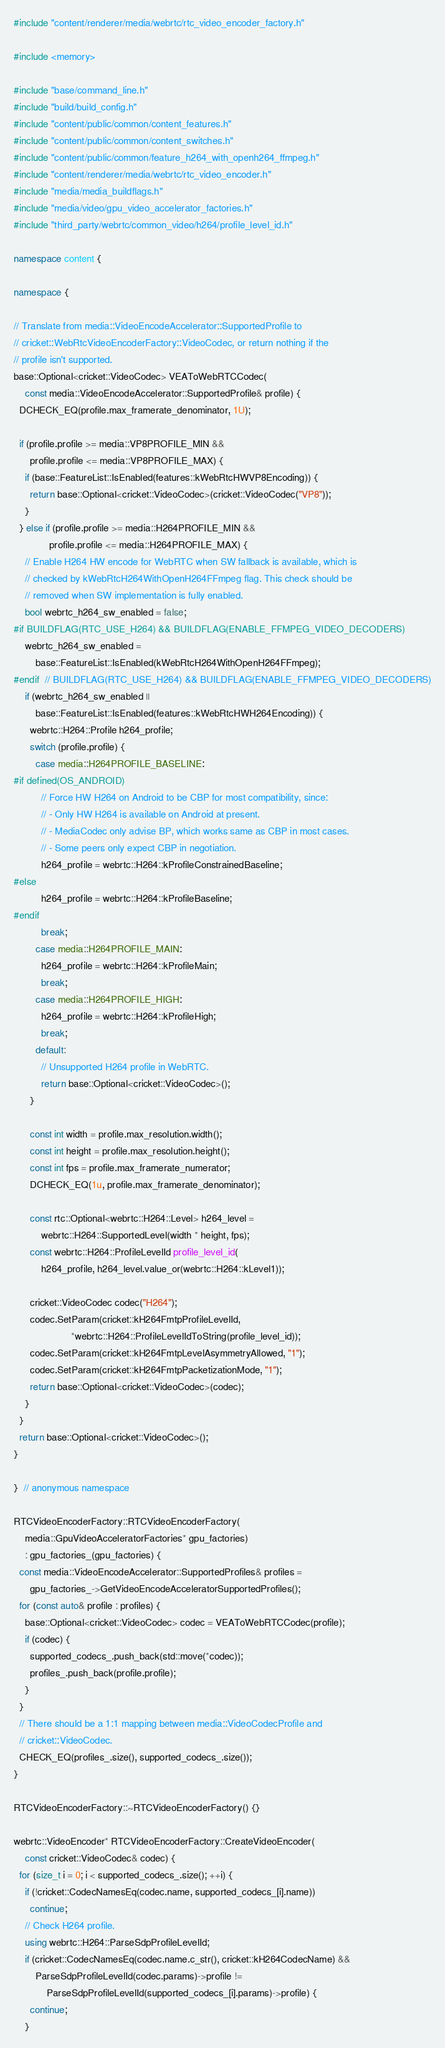<code> <loc_0><loc_0><loc_500><loc_500><_C++_>
#include "content/renderer/media/webrtc/rtc_video_encoder_factory.h"

#include <memory>

#include "base/command_line.h"
#include "build/build_config.h"
#include "content/public/common/content_features.h"
#include "content/public/common/content_switches.h"
#include "content/public/common/feature_h264_with_openh264_ffmpeg.h"
#include "content/renderer/media/webrtc/rtc_video_encoder.h"
#include "media/media_buildflags.h"
#include "media/video/gpu_video_accelerator_factories.h"
#include "third_party/webrtc/common_video/h264/profile_level_id.h"

namespace content {

namespace {

// Translate from media::VideoEncodeAccelerator::SupportedProfile to
// cricket::WebRtcVideoEncoderFactory::VideoCodec, or return nothing if the
// profile isn't supported.
base::Optional<cricket::VideoCodec> VEAToWebRTCCodec(
    const media::VideoEncodeAccelerator::SupportedProfile& profile) {
  DCHECK_EQ(profile.max_framerate_denominator, 1U);

  if (profile.profile >= media::VP8PROFILE_MIN &&
      profile.profile <= media::VP8PROFILE_MAX) {
    if (base::FeatureList::IsEnabled(features::kWebRtcHWVP8Encoding)) {
      return base::Optional<cricket::VideoCodec>(cricket::VideoCodec("VP8"));
    }
  } else if (profile.profile >= media::H264PROFILE_MIN &&
             profile.profile <= media::H264PROFILE_MAX) {
    // Enable H264 HW encode for WebRTC when SW fallback is available, which is
    // checked by kWebRtcH264WithOpenH264FFmpeg flag. This check should be
    // removed when SW implementation is fully enabled.
    bool webrtc_h264_sw_enabled = false;
#if BUILDFLAG(RTC_USE_H264) && BUILDFLAG(ENABLE_FFMPEG_VIDEO_DECODERS)
    webrtc_h264_sw_enabled =
        base::FeatureList::IsEnabled(kWebRtcH264WithOpenH264FFmpeg);
#endif  // BUILDFLAG(RTC_USE_H264) && BUILDFLAG(ENABLE_FFMPEG_VIDEO_DECODERS)
    if (webrtc_h264_sw_enabled ||
        base::FeatureList::IsEnabled(features::kWebRtcHWH264Encoding)) {
      webrtc::H264::Profile h264_profile;
      switch (profile.profile) {
        case media::H264PROFILE_BASELINE:
#if defined(OS_ANDROID)
          // Force HW H264 on Android to be CBP for most compatibility, since:
          // - Only HW H264 is available on Android at present.
          // - MediaCodec only advise BP, which works same as CBP in most cases.
          // - Some peers only expect CBP in negotiation.
          h264_profile = webrtc::H264::kProfileConstrainedBaseline;
#else
          h264_profile = webrtc::H264::kProfileBaseline;
#endif
          break;
        case media::H264PROFILE_MAIN:
          h264_profile = webrtc::H264::kProfileMain;
          break;
        case media::H264PROFILE_HIGH:
          h264_profile = webrtc::H264::kProfileHigh;
          break;
        default:
          // Unsupported H264 profile in WebRTC.
          return base::Optional<cricket::VideoCodec>();
      }

      const int width = profile.max_resolution.width();
      const int height = profile.max_resolution.height();
      const int fps = profile.max_framerate_numerator;
      DCHECK_EQ(1u, profile.max_framerate_denominator);

      const rtc::Optional<webrtc::H264::Level> h264_level =
          webrtc::H264::SupportedLevel(width * height, fps);
      const webrtc::H264::ProfileLevelId profile_level_id(
          h264_profile, h264_level.value_or(webrtc::H264::kLevel1));

      cricket::VideoCodec codec("H264");
      codec.SetParam(cricket::kH264FmtpProfileLevelId,
                     *webrtc::H264::ProfileLevelIdToString(profile_level_id));
      codec.SetParam(cricket::kH264FmtpLevelAsymmetryAllowed, "1");
      codec.SetParam(cricket::kH264FmtpPacketizationMode, "1");
      return base::Optional<cricket::VideoCodec>(codec);
    }
  }
  return base::Optional<cricket::VideoCodec>();
}

}  // anonymous namespace

RTCVideoEncoderFactory::RTCVideoEncoderFactory(
    media::GpuVideoAcceleratorFactories* gpu_factories)
    : gpu_factories_(gpu_factories) {
  const media::VideoEncodeAccelerator::SupportedProfiles& profiles =
      gpu_factories_->GetVideoEncodeAcceleratorSupportedProfiles();
  for (const auto& profile : profiles) {
    base::Optional<cricket::VideoCodec> codec = VEAToWebRTCCodec(profile);
    if (codec) {
      supported_codecs_.push_back(std::move(*codec));
      profiles_.push_back(profile.profile);
    }
  }
  // There should be a 1:1 mapping between media::VideoCodecProfile and
  // cricket::VideoCodec.
  CHECK_EQ(profiles_.size(), supported_codecs_.size());
}

RTCVideoEncoderFactory::~RTCVideoEncoderFactory() {}

webrtc::VideoEncoder* RTCVideoEncoderFactory::CreateVideoEncoder(
    const cricket::VideoCodec& codec) {
  for (size_t i = 0; i < supported_codecs_.size(); ++i) {
    if (!cricket::CodecNamesEq(codec.name, supported_codecs_[i].name))
      continue;
    // Check H264 profile.
    using webrtc::H264::ParseSdpProfileLevelId;
    if (cricket::CodecNamesEq(codec.name.c_str(), cricket::kH264CodecName) &&
        ParseSdpProfileLevelId(codec.params)->profile !=
            ParseSdpProfileLevelId(supported_codecs_[i].params)->profile) {
      continue;
    }</code> 